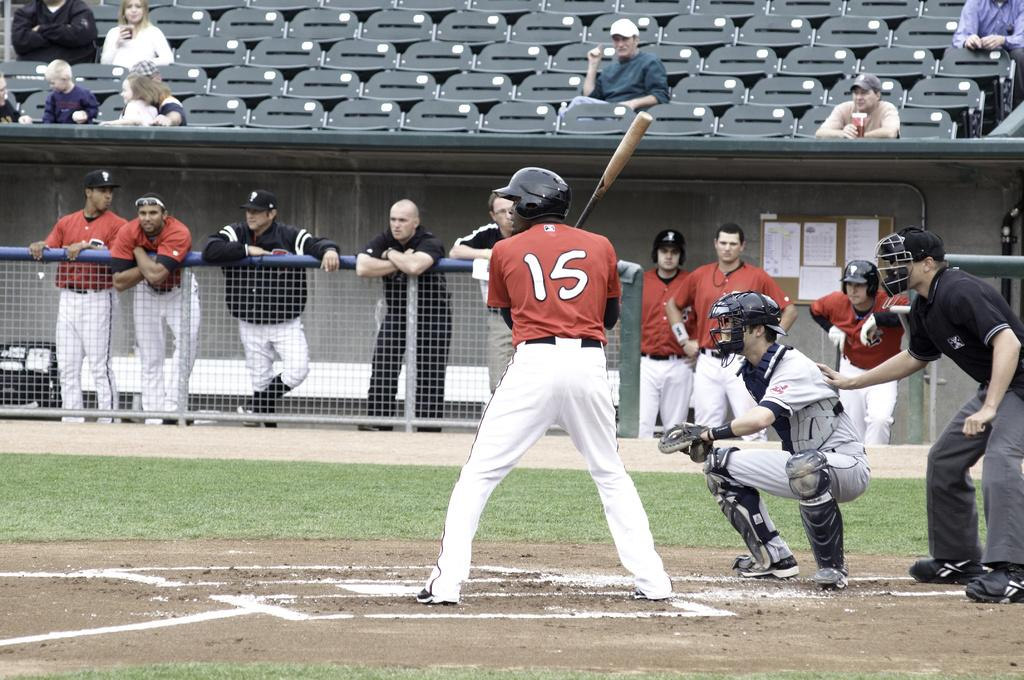<image>
Write a terse but informative summary of the picture. The player at bat is wearing the number 15 